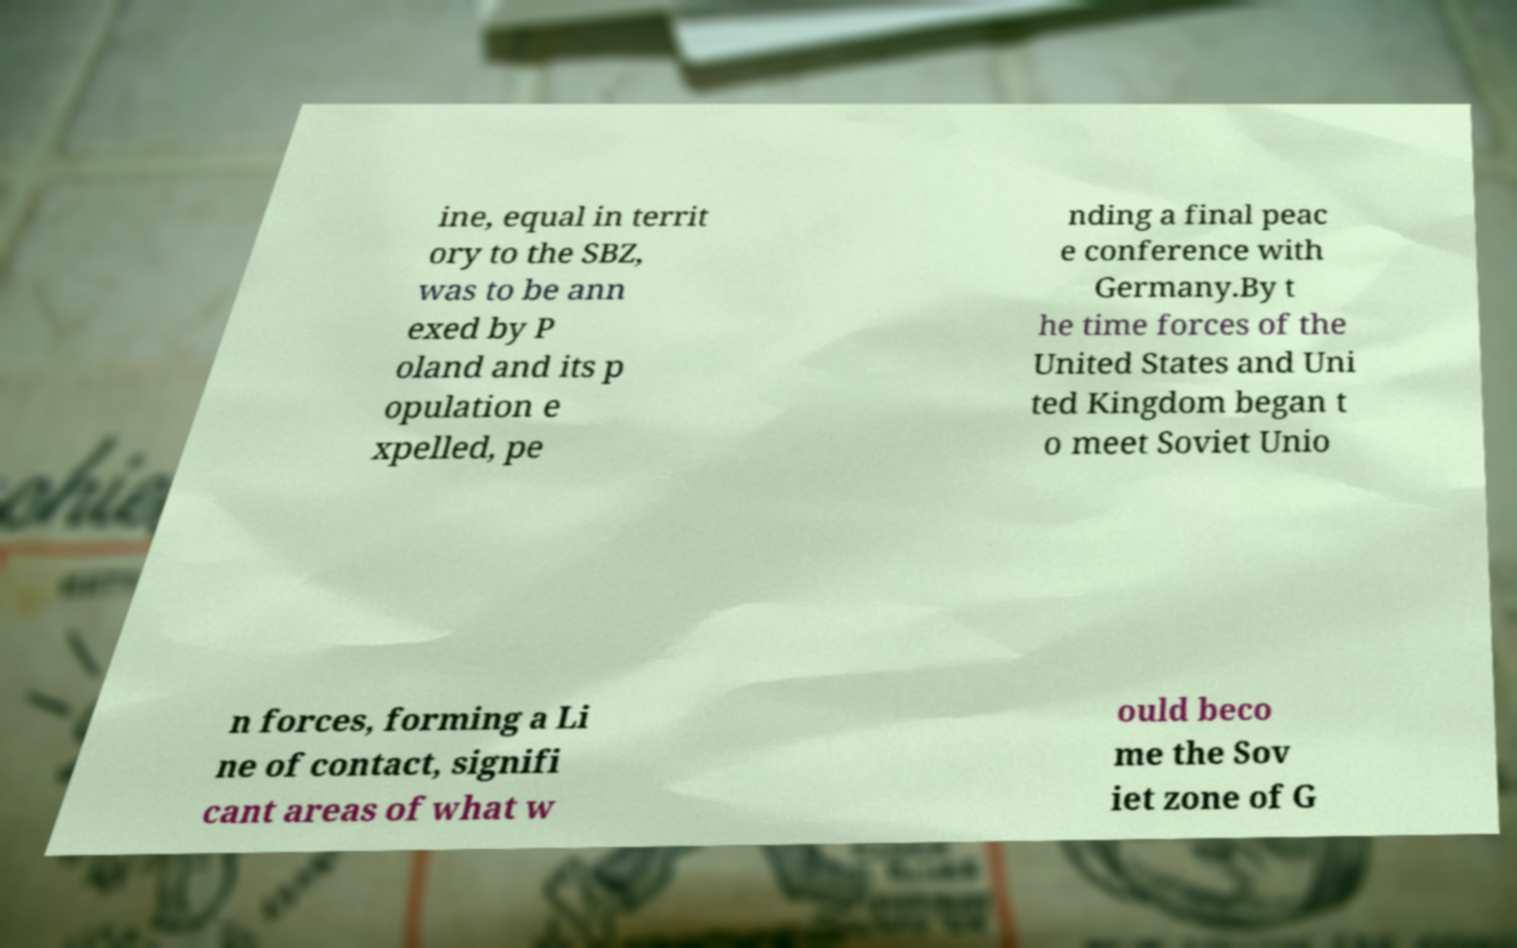Could you extract and type out the text from this image? ine, equal in territ ory to the SBZ, was to be ann exed by P oland and its p opulation e xpelled, pe nding a final peac e conference with Germany.By t he time forces of the United States and Uni ted Kingdom began t o meet Soviet Unio n forces, forming a Li ne of contact, signifi cant areas of what w ould beco me the Sov iet zone of G 